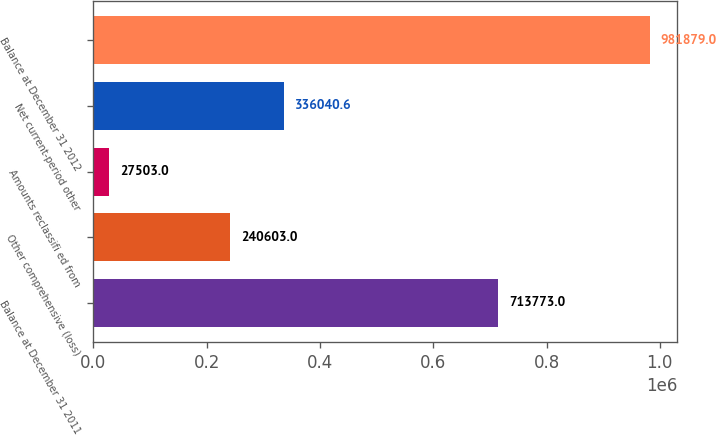<chart> <loc_0><loc_0><loc_500><loc_500><bar_chart><fcel>Balance at December 31 2011<fcel>Other comprehensive (loss)<fcel>Amounts reclassifi ed from<fcel>Net current-period other<fcel>Balance at December 31 2012<nl><fcel>713773<fcel>240603<fcel>27503<fcel>336041<fcel>981879<nl></chart> 